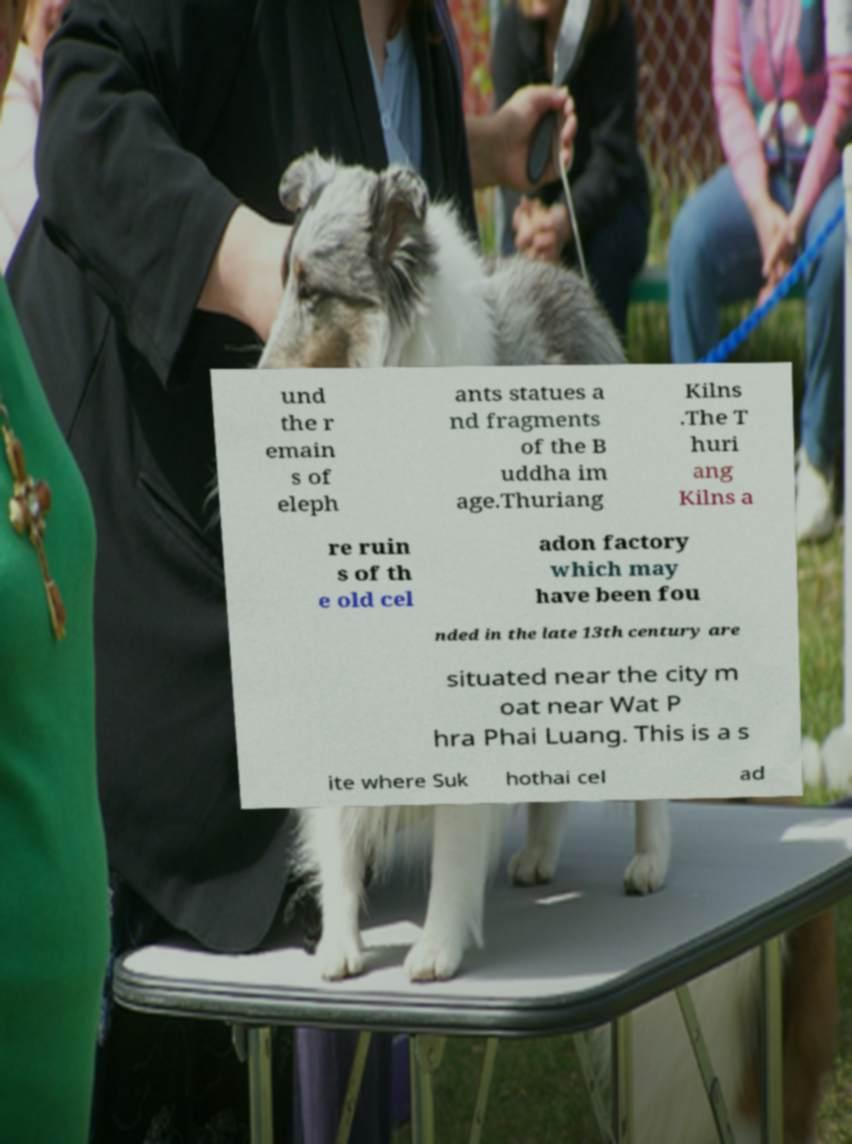For documentation purposes, I need the text within this image transcribed. Could you provide that? und the r emain s of eleph ants statues a nd fragments of the B uddha im age.Thuriang Kilns .The T huri ang Kilns a re ruin s of th e old cel adon factory which may have been fou nded in the late 13th century are situated near the city m oat near Wat P hra Phai Luang. This is a s ite where Suk hothai cel ad 